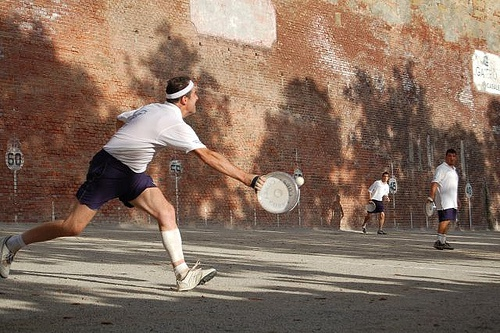Describe the objects in this image and their specific colors. I can see people in tan, lightgray, black, gray, and maroon tones, people in tan, lightgray, gray, black, and darkgray tones, frisbee in tan, lightgray, darkgray, and gray tones, people in tan, white, black, maroon, and gray tones, and frisbee in tan, gray, black, and darkgray tones in this image. 